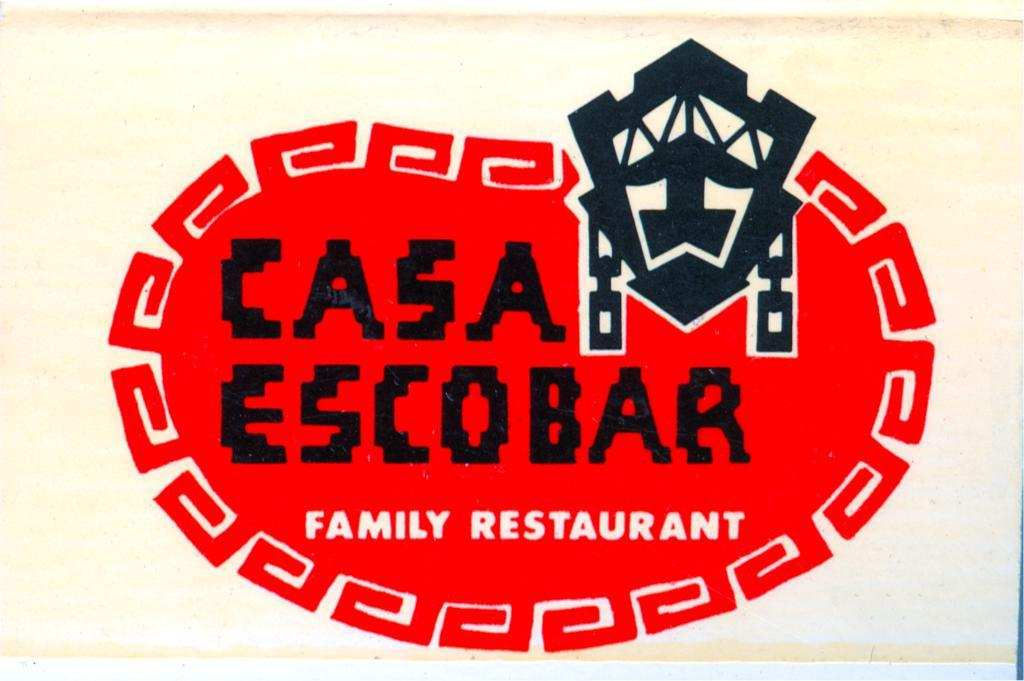<image>
Share a concise interpretation of the image provided. Casa Escobar is a restaurant that's perfect for the family to enjoy. 